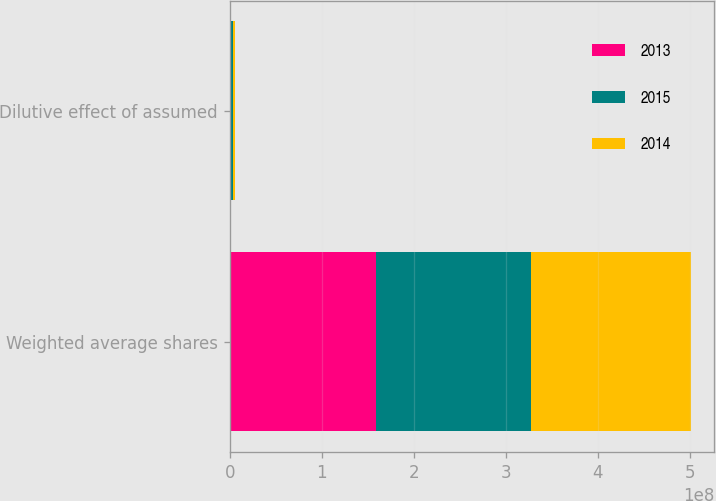Convert chart to OTSL. <chart><loc_0><loc_0><loc_500><loc_500><stacked_bar_chart><ecel><fcel>Weighted average shares<fcel>Dilutive effect of assumed<nl><fcel>2013<fcel>1.59172e+08<fcel>1.553e+06<nl><fcel>2015<fcel>1.68842e+08<fcel>2.15e+06<nl><fcel>2014<fcel>1.73547e+08<fcel>2.276e+06<nl></chart> 